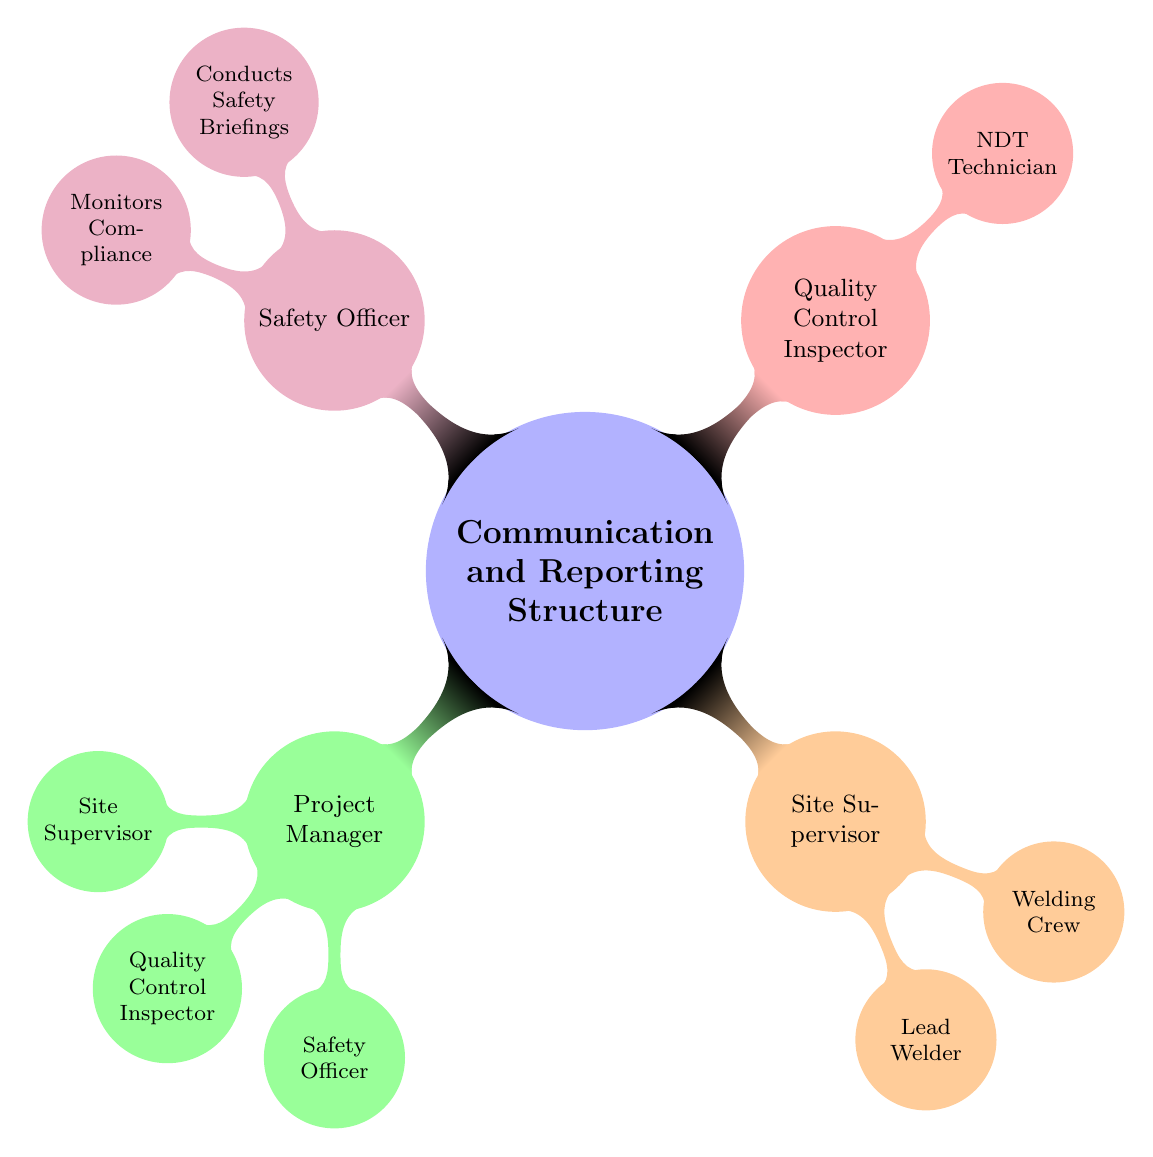What is the role of the Project Manager? The Project Manager oversees all aspects of the welder's work on site, as described in the diagram.
Answer: Oversees all aspects of the welder's work on site Who does the Site Supervisor report to? The diagram indicates that the Site Supervisor reports directly to the Project Manager, which can be found by following the reporting lines.
Answer: Project Manager How many direct reports does the Project Manager have? Counting the nodes connected to the Project Manager, we find three direct reports: Site Supervisor, Quality Control Inspector, and Safety Officer.
Answer: Three What does the Quality Control Inspector do? The diagram specifies that the Quality Control Inspector ensures that the welding quality meets standards, providing a clear understanding of their role.
Answer: Ensures welding quality meets standards Who supervises the Welding Crew? The diagram shows that the Welding Crew reports to the Lead Welder, who is managed by the Site Supervisor, establishing the supervision chain.
Answer: Lead Welder What role does the NDT Technician play? According to the diagram, the NDT Technician conducts nondestructive tests, indicating their specialized function within the Quality Control process.
Answer: Conducts nondestructive tests What responsibilities does the Safety Officer have? The diagram lists two key responsibilities for the Safety Officer: Conducts Safety Briefings and Monitors Compliance, showcasing their roles in site safety.
Answer: Conducts Safety Briefings, Monitors Compliance What is the relationship between the Site Supervisor and Lead Welder? The diagram indicates that the Lead Welder reports to the Site Supervisor, establishing a direct supervisory relationship between them.
Answer: Site Supervisor supervises Lead Welder How many levels are present in the reporting structure from the Project Manager? The diagram illustrates a structured hierarchy with three levels of reporting beneath the Project Manager: Site Supervisor, Quality Control Inspector, and Safety Officer.
Answer: Three levels 